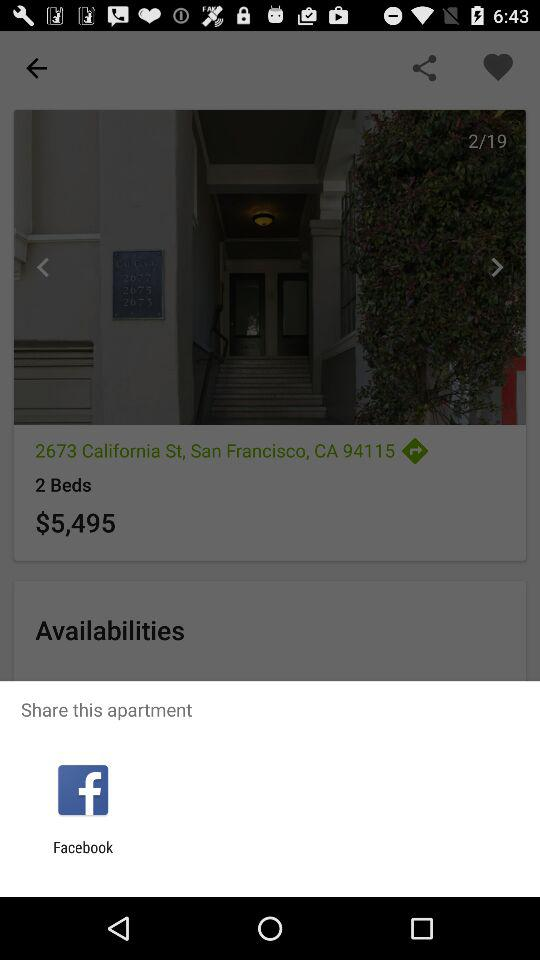What is the address? The address is 2673 California St, San Francisco, CA 94115. 